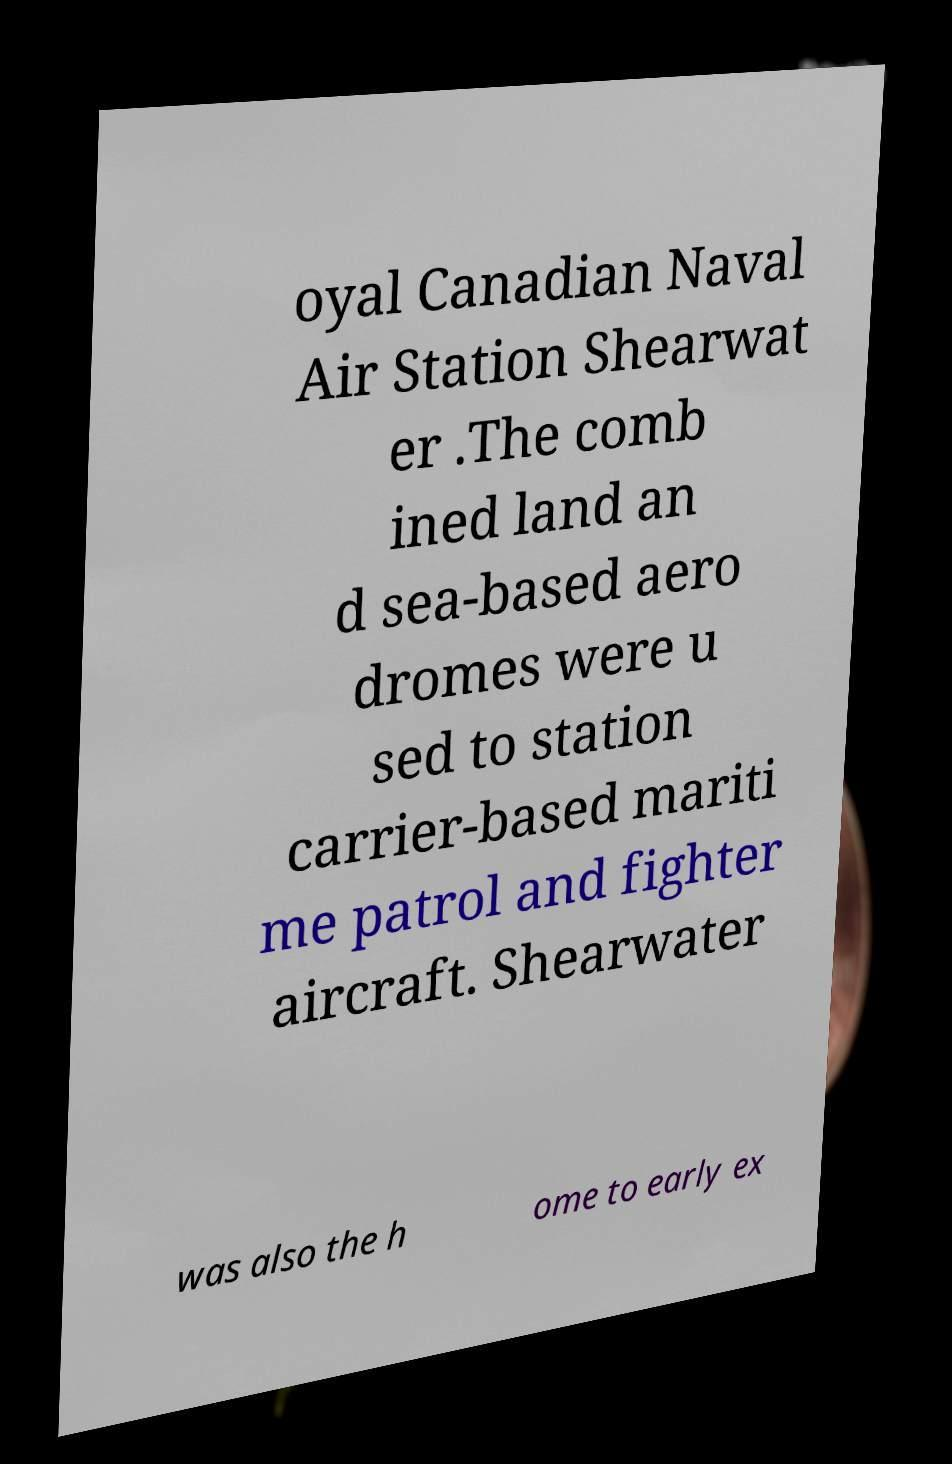What messages or text are displayed in this image? I need them in a readable, typed format. oyal Canadian Naval Air Station Shearwat er .The comb ined land an d sea-based aero dromes were u sed to station carrier-based mariti me patrol and fighter aircraft. Shearwater was also the h ome to early ex 